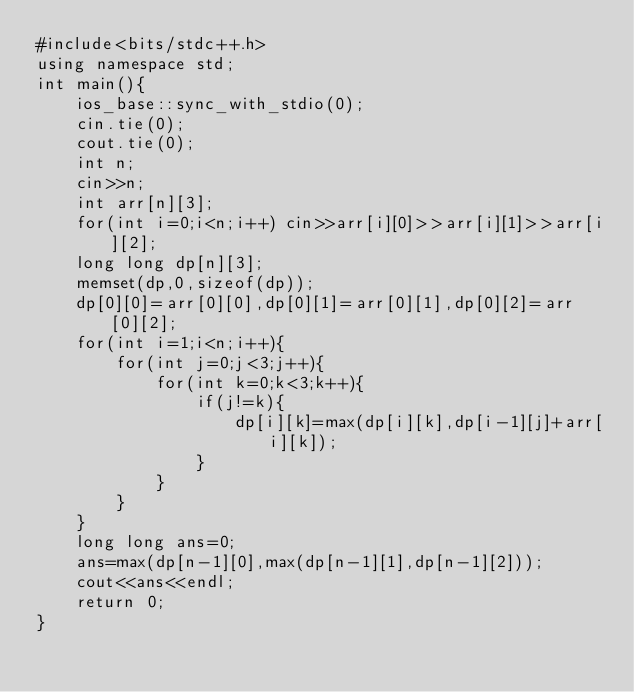<code> <loc_0><loc_0><loc_500><loc_500><_C++_>#include<bits/stdc++.h>
using namespace std;
int main(){
    ios_base::sync_with_stdio(0);
    cin.tie(0);
    cout.tie(0);
    int n;
    cin>>n;
    int arr[n][3];
    for(int i=0;i<n;i++) cin>>arr[i][0]>>arr[i][1]>>arr[i][2];
    long long dp[n][3];
    memset(dp,0,sizeof(dp));
    dp[0][0]=arr[0][0],dp[0][1]=arr[0][1],dp[0][2]=arr[0][2];
    for(int i=1;i<n;i++){
        for(int j=0;j<3;j++){
            for(int k=0;k<3;k++){
                if(j!=k){
                    dp[i][k]=max(dp[i][k],dp[i-1][j]+arr[i][k]);
                }
            }
        }
    }
    long long ans=0;
    ans=max(dp[n-1][0],max(dp[n-1][1],dp[n-1][2]));
    cout<<ans<<endl;
    return 0;
}</code> 